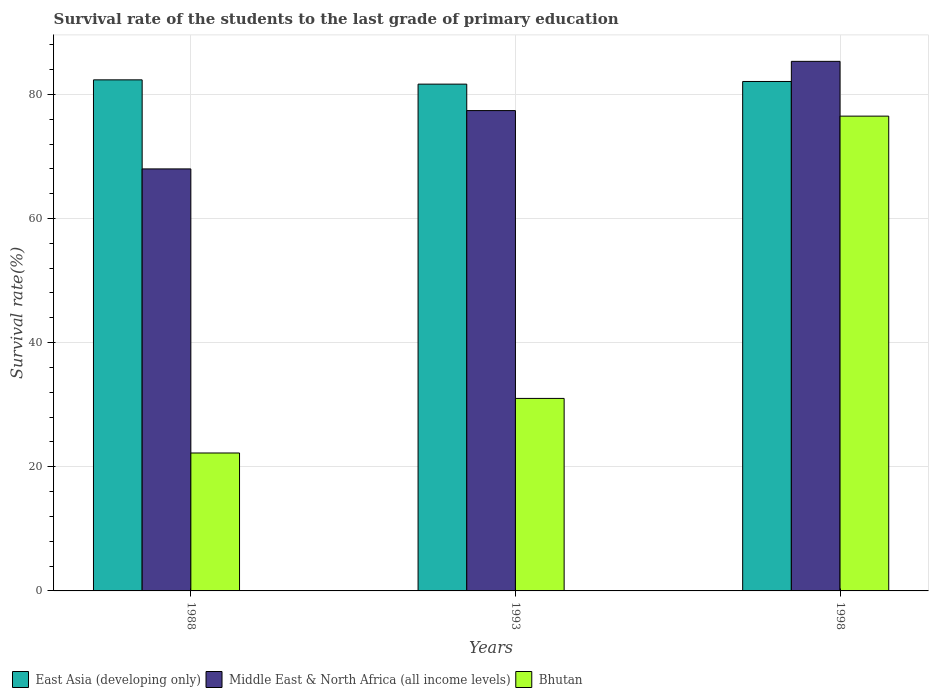How many different coloured bars are there?
Keep it short and to the point. 3. What is the survival rate of the students in East Asia (developing only) in 1993?
Your answer should be compact. 81.65. Across all years, what is the maximum survival rate of the students in Middle East & North Africa (all income levels)?
Your answer should be very brief. 85.32. Across all years, what is the minimum survival rate of the students in East Asia (developing only)?
Offer a terse response. 81.65. What is the total survival rate of the students in East Asia (developing only) in the graph?
Your response must be concise. 246.07. What is the difference between the survival rate of the students in East Asia (developing only) in 1988 and that in 1998?
Offer a very short reply. 0.26. What is the difference between the survival rate of the students in Bhutan in 1988 and the survival rate of the students in East Asia (developing only) in 1998?
Make the answer very short. -59.86. What is the average survival rate of the students in Bhutan per year?
Keep it short and to the point. 43.24. In the year 1993, what is the difference between the survival rate of the students in Bhutan and survival rate of the students in East Asia (developing only)?
Your answer should be very brief. -50.63. What is the ratio of the survival rate of the students in Bhutan in 1993 to that in 1998?
Provide a short and direct response. 0.41. Is the survival rate of the students in East Asia (developing only) in 1988 less than that in 1998?
Make the answer very short. No. Is the difference between the survival rate of the students in Bhutan in 1993 and 1998 greater than the difference between the survival rate of the students in East Asia (developing only) in 1993 and 1998?
Make the answer very short. No. What is the difference between the highest and the second highest survival rate of the students in Middle East & North Africa (all income levels)?
Offer a terse response. 7.93. What is the difference between the highest and the lowest survival rate of the students in Bhutan?
Keep it short and to the point. 54.27. What does the 2nd bar from the left in 1988 represents?
Provide a short and direct response. Middle East & North Africa (all income levels). What does the 1st bar from the right in 1998 represents?
Ensure brevity in your answer.  Bhutan. Are all the bars in the graph horizontal?
Your response must be concise. No. How many years are there in the graph?
Provide a short and direct response. 3. Are the values on the major ticks of Y-axis written in scientific E-notation?
Offer a very short reply. No. How are the legend labels stacked?
Offer a very short reply. Horizontal. What is the title of the graph?
Your response must be concise. Survival rate of the students to the last grade of primary education. Does "Low income" appear as one of the legend labels in the graph?
Your answer should be very brief. No. What is the label or title of the X-axis?
Offer a very short reply. Years. What is the label or title of the Y-axis?
Your answer should be compact. Survival rate(%). What is the Survival rate(%) in East Asia (developing only) in 1988?
Make the answer very short. 82.34. What is the Survival rate(%) of Middle East & North Africa (all income levels) in 1988?
Give a very brief answer. 67.99. What is the Survival rate(%) of Bhutan in 1988?
Your response must be concise. 22.22. What is the Survival rate(%) of East Asia (developing only) in 1993?
Make the answer very short. 81.65. What is the Survival rate(%) in Middle East & North Africa (all income levels) in 1993?
Provide a short and direct response. 77.39. What is the Survival rate(%) in Bhutan in 1993?
Ensure brevity in your answer.  31.02. What is the Survival rate(%) of East Asia (developing only) in 1998?
Offer a terse response. 82.08. What is the Survival rate(%) in Middle East & North Africa (all income levels) in 1998?
Keep it short and to the point. 85.32. What is the Survival rate(%) of Bhutan in 1998?
Provide a short and direct response. 76.49. Across all years, what is the maximum Survival rate(%) in East Asia (developing only)?
Offer a very short reply. 82.34. Across all years, what is the maximum Survival rate(%) of Middle East & North Africa (all income levels)?
Your answer should be compact. 85.32. Across all years, what is the maximum Survival rate(%) in Bhutan?
Offer a very short reply. 76.49. Across all years, what is the minimum Survival rate(%) in East Asia (developing only)?
Your answer should be compact. 81.65. Across all years, what is the minimum Survival rate(%) of Middle East & North Africa (all income levels)?
Provide a short and direct response. 67.99. Across all years, what is the minimum Survival rate(%) of Bhutan?
Ensure brevity in your answer.  22.22. What is the total Survival rate(%) of East Asia (developing only) in the graph?
Offer a terse response. 246.07. What is the total Survival rate(%) in Middle East & North Africa (all income levels) in the graph?
Offer a terse response. 230.7. What is the total Survival rate(%) in Bhutan in the graph?
Your response must be concise. 129.73. What is the difference between the Survival rate(%) in East Asia (developing only) in 1988 and that in 1993?
Provide a succinct answer. 0.69. What is the difference between the Survival rate(%) of Middle East & North Africa (all income levels) in 1988 and that in 1993?
Keep it short and to the point. -9.4. What is the difference between the Survival rate(%) of Bhutan in 1988 and that in 1993?
Provide a short and direct response. -8.79. What is the difference between the Survival rate(%) in East Asia (developing only) in 1988 and that in 1998?
Ensure brevity in your answer.  0.26. What is the difference between the Survival rate(%) of Middle East & North Africa (all income levels) in 1988 and that in 1998?
Make the answer very short. -17.33. What is the difference between the Survival rate(%) in Bhutan in 1988 and that in 1998?
Make the answer very short. -54.27. What is the difference between the Survival rate(%) of East Asia (developing only) in 1993 and that in 1998?
Ensure brevity in your answer.  -0.43. What is the difference between the Survival rate(%) of Middle East & North Africa (all income levels) in 1993 and that in 1998?
Ensure brevity in your answer.  -7.93. What is the difference between the Survival rate(%) in Bhutan in 1993 and that in 1998?
Your answer should be very brief. -45.48. What is the difference between the Survival rate(%) of East Asia (developing only) in 1988 and the Survival rate(%) of Middle East & North Africa (all income levels) in 1993?
Your response must be concise. 4.95. What is the difference between the Survival rate(%) in East Asia (developing only) in 1988 and the Survival rate(%) in Bhutan in 1993?
Offer a very short reply. 51.33. What is the difference between the Survival rate(%) in Middle East & North Africa (all income levels) in 1988 and the Survival rate(%) in Bhutan in 1993?
Provide a succinct answer. 36.98. What is the difference between the Survival rate(%) in East Asia (developing only) in 1988 and the Survival rate(%) in Middle East & North Africa (all income levels) in 1998?
Provide a succinct answer. -2.98. What is the difference between the Survival rate(%) of East Asia (developing only) in 1988 and the Survival rate(%) of Bhutan in 1998?
Provide a succinct answer. 5.85. What is the difference between the Survival rate(%) in Middle East & North Africa (all income levels) in 1988 and the Survival rate(%) in Bhutan in 1998?
Give a very brief answer. -8.5. What is the difference between the Survival rate(%) in East Asia (developing only) in 1993 and the Survival rate(%) in Middle East & North Africa (all income levels) in 1998?
Your response must be concise. -3.67. What is the difference between the Survival rate(%) in East Asia (developing only) in 1993 and the Survival rate(%) in Bhutan in 1998?
Offer a very short reply. 5.16. What is the difference between the Survival rate(%) in Middle East & North Africa (all income levels) in 1993 and the Survival rate(%) in Bhutan in 1998?
Keep it short and to the point. 0.89. What is the average Survival rate(%) of East Asia (developing only) per year?
Make the answer very short. 82.02. What is the average Survival rate(%) in Middle East & North Africa (all income levels) per year?
Offer a very short reply. 76.9. What is the average Survival rate(%) in Bhutan per year?
Ensure brevity in your answer.  43.24. In the year 1988, what is the difference between the Survival rate(%) of East Asia (developing only) and Survival rate(%) of Middle East & North Africa (all income levels)?
Make the answer very short. 14.35. In the year 1988, what is the difference between the Survival rate(%) of East Asia (developing only) and Survival rate(%) of Bhutan?
Offer a very short reply. 60.12. In the year 1988, what is the difference between the Survival rate(%) of Middle East & North Africa (all income levels) and Survival rate(%) of Bhutan?
Keep it short and to the point. 45.77. In the year 1993, what is the difference between the Survival rate(%) in East Asia (developing only) and Survival rate(%) in Middle East & North Africa (all income levels)?
Offer a very short reply. 4.26. In the year 1993, what is the difference between the Survival rate(%) of East Asia (developing only) and Survival rate(%) of Bhutan?
Make the answer very short. 50.63. In the year 1993, what is the difference between the Survival rate(%) of Middle East & North Africa (all income levels) and Survival rate(%) of Bhutan?
Provide a short and direct response. 46.37. In the year 1998, what is the difference between the Survival rate(%) of East Asia (developing only) and Survival rate(%) of Middle East & North Africa (all income levels)?
Make the answer very short. -3.24. In the year 1998, what is the difference between the Survival rate(%) in East Asia (developing only) and Survival rate(%) in Bhutan?
Give a very brief answer. 5.58. In the year 1998, what is the difference between the Survival rate(%) in Middle East & North Africa (all income levels) and Survival rate(%) in Bhutan?
Offer a terse response. 8.83. What is the ratio of the Survival rate(%) of East Asia (developing only) in 1988 to that in 1993?
Provide a short and direct response. 1.01. What is the ratio of the Survival rate(%) in Middle East & North Africa (all income levels) in 1988 to that in 1993?
Offer a very short reply. 0.88. What is the ratio of the Survival rate(%) in Bhutan in 1988 to that in 1993?
Give a very brief answer. 0.72. What is the ratio of the Survival rate(%) of Middle East & North Africa (all income levels) in 1988 to that in 1998?
Ensure brevity in your answer.  0.8. What is the ratio of the Survival rate(%) of Bhutan in 1988 to that in 1998?
Your answer should be very brief. 0.29. What is the ratio of the Survival rate(%) in East Asia (developing only) in 1993 to that in 1998?
Provide a succinct answer. 0.99. What is the ratio of the Survival rate(%) in Middle East & North Africa (all income levels) in 1993 to that in 1998?
Your response must be concise. 0.91. What is the ratio of the Survival rate(%) in Bhutan in 1993 to that in 1998?
Your response must be concise. 0.41. What is the difference between the highest and the second highest Survival rate(%) of East Asia (developing only)?
Give a very brief answer. 0.26. What is the difference between the highest and the second highest Survival rate(%) in Middle East & North Africa (all income levels)?
Give a very brief answer. 7.93. What is the difference between the highest and the second highest Survival rate(%) in Bhutan?
Make the answer very short. 45.48. What is the difference between the highest and the lowest Survival rate(%) of East Asia (developing only)?
Keep it short and to the point. 0.69. What is the difference between the highest and the lowest Survival rate(%) of Middle East & North Africa (all income levels)?
Offer a very short reply. 17.33. What is the difference between the highest and the lowest Survival rate(%) of Bhutan?
Offer a very short reply. 54.27. 